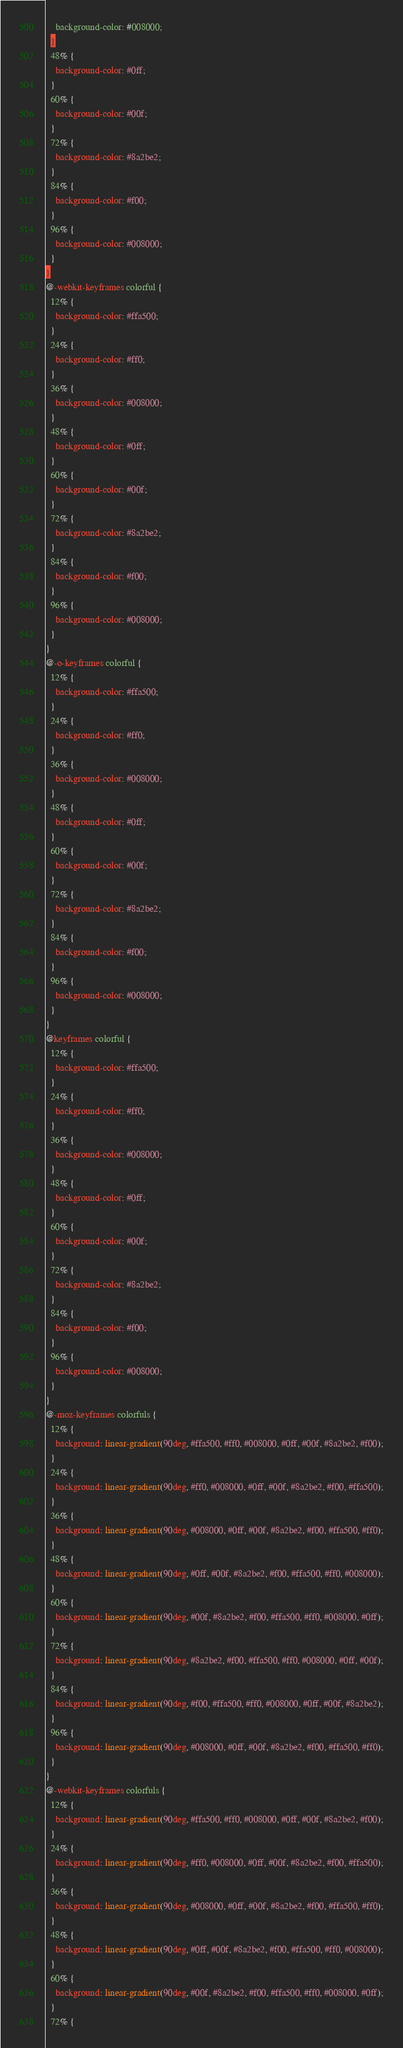<code> <loc_0><loc_0><loc_500><loc_500><_CSS_>    background-color: #008000;
  }
  48% {
    background-color: #0ff;
  }
  60% {
    background-color: #00f;
  }
  72% {
    background-color: #8a2be2;
  }
  84% {
    background-color: #f00;
  }
  96% {
    background-color: #008000;
  }
}
@-webkit-keyframes colorful {
  12% {
    background-color: #ffa500;
  }
  24% {
    background-color: #ff0;
  }
  36% {
    background-color: #008000;
  }
  48% {
    background-color: #0ff;
  }
  60% {
    background-color: #00f;
  }
  72% {
    background-color: #8a2be2;
  }
  84% {
    background-color: #f00;
  }
  96% {
    background-color: #008000;
  }
}
@-o-keyframes colorful {
  12% {
    background-color: #ffa500;
  }
  24% {
    background-color: #ff0;
  }
  36% {
    background-color: #008000;
  }
  48% {
    background-color: #0ff;
  }
  60% {
    background-color: #00f;
  }
  72% {
    background-color: #8a2be2;
  }
  84% {
    background-color: #f00;
  }
  96% {
    background-color: #008000;
  }
}
@keyframes colorful {
  12% {
    background-color: #ffa500;
  }
  24% {
    background-color: #ff0;
  }
  36% {
    background-color: #008000;
  }
  48% {
    background-color: #0ff;
  }
  60% {
    background-color: #00f;
  }
  72% {
    background-color: #8a2be2;
  }
  84% {
    background-color: #f00;
  }
  96% {
    background-color: #008000;
  }
}
@-moz-keyframes colorfuls {
  12% {
    background: linear-gradient(90deg, #ffa500, #ff0, #008000, #0ff, #00f, #8a2be2, #f00);
  }
  24% {
    background: linear-gradient(90deg, #ff0, #008000, #0ff, #00f, #8a2be2, #f00, #ffa500);
  }
  36% {
    background: linear-gradient(90deg, #008000, #0ff, #00f, #8a2be2, #f00, #ffa500, #ff0);
  }
  48% {
    background: linear-gradient(90deg, #0ff, #00f, #8a2be2, #f00, #ffa500, #ff0, #008000);
  }
  60% {
    background: linear-gradient(90deg, #00f, #8a2be2, #f00, #ffa500, #ff0, #008000, #0ff);
  }
  72% {
    background: linear-gradient(90deg, #8a2be2, #f00, #ffa500, #ff0, #008000, #0ff, #00f);
  }
  84% {
    background: linear-gradient(90deg, #f00, #ffa500, #ff0, #008000, #0ff, #00f, #8a2be2);
  }
  96% {
    background: linear-gradient(90deg, #008000, #0ff, #00f, #8a2be2, #f00, #ffa500, #ff0);
  }
}
@-webkit-keyframes colorfuls {
  12% {
    background: linear-gradient(90deg, #ffa500, #ff0, #008000, #0ff, #00f, #8a2be2, #f00);
  }
  24% {
    background: linear-gradient(90deg, #ff0, #008000, #0ff, #00f, #8a2be2, #f00, #ffa500);
  }
  36% {
    background: linear-gradient(90deg, #008000, #0ff, #00f, #8a2be2, #f00, #ffa500, #ff0);
  }
  48% {
    background: linear-gradient(90deg, #0ff, #00f, #8a2be2, #f00, #ffa500, #ff0, #008000);
  }
  60% {
    background: linear-gradient(90deg, #00f, #8a2be2, #f00, #ffa500, #ff0, #008000, #0ff);
  }
  72% {</code> 